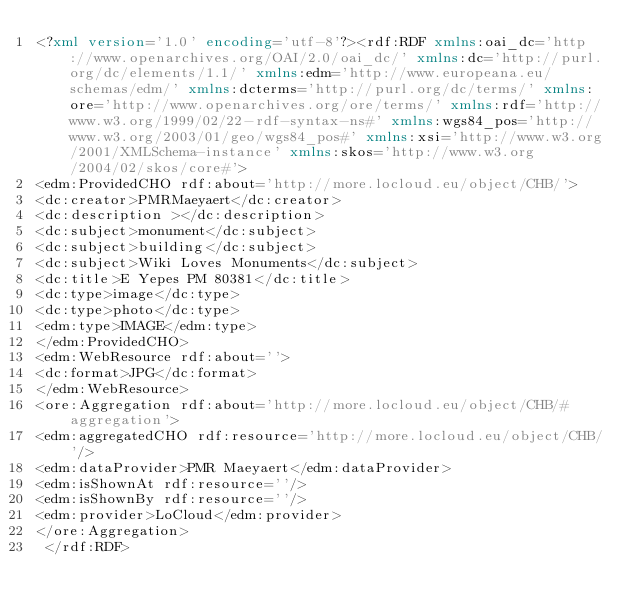Convert code to text. <code><loc_0><loc_0><loc_500><loc_500><_XML_><?xml version='1.0' encoding='utf-8'?><rdf:RDF xmlns:oai_dc='http://www.openarchives.org/OAI/2.0/oai_dc/' xmlns:dc='http://purl.org/dc/elements/1.1/' xmlns:edm='http://www.europeana.eu/schemas/edm/' xmlns:dcterms='http://purl.org/dc/terms/' xmlns:ore='http://www.openarchives.org/ore/terms/' xmlns:rdf='http://www.w3.org/1999/02/22-rdf-syntax-ns#' xmlns:wgs84_pos='http://www.w3.org/2003/01/geo/wgs84_pos#' xmlns:xsi='http://www.w3.org/2001/XMLSchema-instance' xmlns:skos='http://www.w3.org/2004/02/skos/core#'>
<edm:ProvidedCHO rdf:about='http://more.locloud.eu/object/CHB/'>
<dc:creator>PMRMaeyaert</dc:creator>
<dc:description ></dc:description>
<dc:subject>monument</dc:subject>
<dc:subject>building</dc:subject>
<dc:subject>Wiki Loves Monuments</dc:subject>
<dc:title>E Yepes PM 80381</dc:title>
<dc:type>image</dc:type>
<dc:type>photo</dc:type>
<edm:type>IMAGE</edm:type>
</edm:ProvidedCHO>
<edm:WebResource rdf:about=''>
<dc:format>JPG</dc:format>
</edm:WebResource>
<ore:Aggregation rdf:about='http://more.locloud.eu/object/CHB/#aggregation'>
<edm:aggregatedCHO rdf:resource='http://more.locloud.eu/object/CHB/'/>
<edm:dataProvider>PMR Maeyaert</edm:dataProvider>
<edm:isShownAt rdf:resource=''/>
<edm:isShownBy rdf:resource=''/>
<edm:provider>LoCloud</edm:provider>
</ore:Aggregation>
 </rdf:RDF>
</code> 